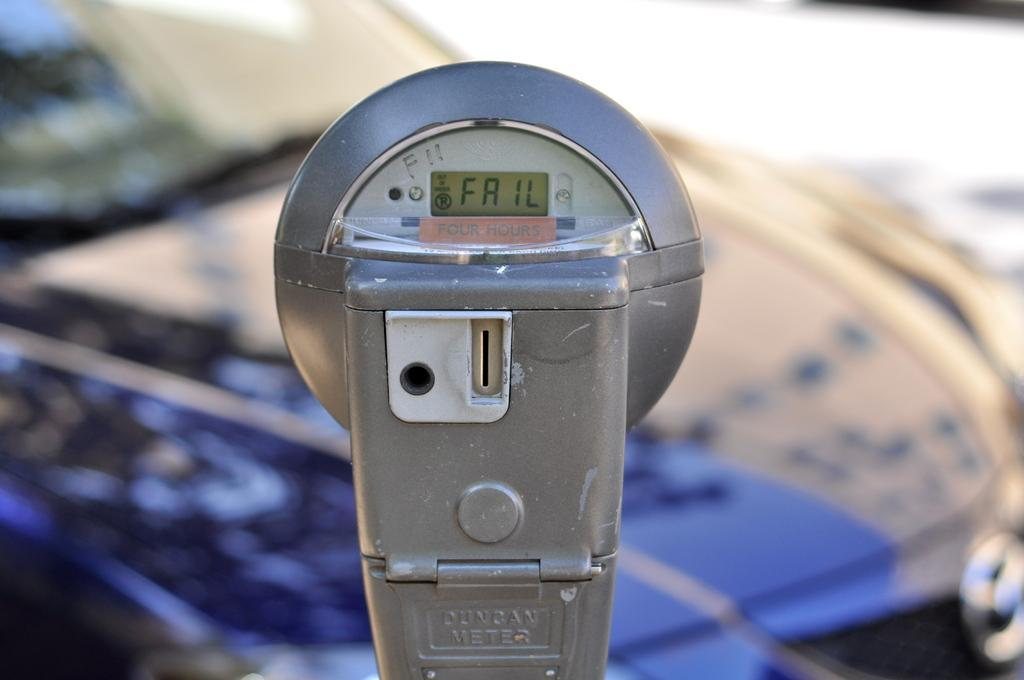What object is the main focus of the image? There is a parking meter in the image. Can you describe anything else visible in the image? There is a car in the background of the image. What type of religious symbol can be seen on the parking meter? There is no religious symbol present on the parking meter in the image. What type of nail is being used to secure the parking meter to the ground? The image does not show any nails or their type, as it focuses on the parking meter and the car in the background. 